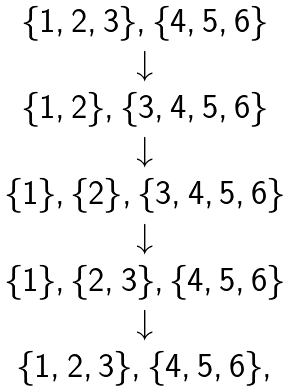<formula> <loc_0><loc_0><loc_500><loc_500>\begin{array} { c } \{ 1 , 2 , 3 \} , \{ 4 , 5 , 6 \} \\ \downarrow \\ \{ 1 , 2 \} , \{ 3 , 4 , 5 , 6 \} \\ \downarrow \\ \{ 1 \} , \{ 2 \} , \{ 3 , 4 , 5 , 6 \} \\ \downarrow \\ \{ 1 \} , \{ 2 , 3 \} , \{ 4 , 5 , 6 \} \\ \downarrow \\ \{ 1 , 2 , 3 \} , \{ 4 , 5 , 6 \} , \\ \end{array}</formula> 